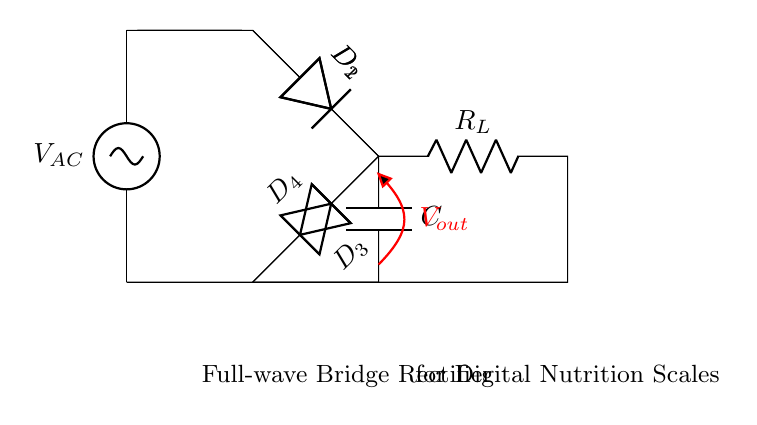What is the type of rectifier shown in this diagram? The diagram illustrates a full-wave bridge rectifier, indicated by the arrangement of four diodes that convert alternating current to direct current.
Answer: Full-wave bridge rectifier How many diodes are used in this circuit? The circuit contains four diodes (D1, D2, D3, D4), which are evident from the labeled components in the diagram.
Answer: Four diodes What is the role of the capacitor in this circuit? The capacitor stores energy and smooths out the output voltage, providing a steadier direct current to the load resistor by reducing voltage ripples.
Answer: Smoothing output What is the function of the load resistor identified as R_L? The load resistor R_L represents a component connected to consume the electrical energy, demonstrating where the output from the rectifier supplies power to a load.
Answer: Consumes output power How does this circuit convert AC to DC? The full-wave bridge rectifier uses four diodes in a specific configuration to allow both halves of the AC waveform to become positive, effectively doubling the frequency of the output waveform.
Answer: Converts AC to DC by diodes What is the output voltage indicated in the diagram? The output voltage \( V_{out} \) is marked in red, emphasizing the voltage available across the output terminals of the rectifier once it processes the incoming AC signal.
Answer: V_out 